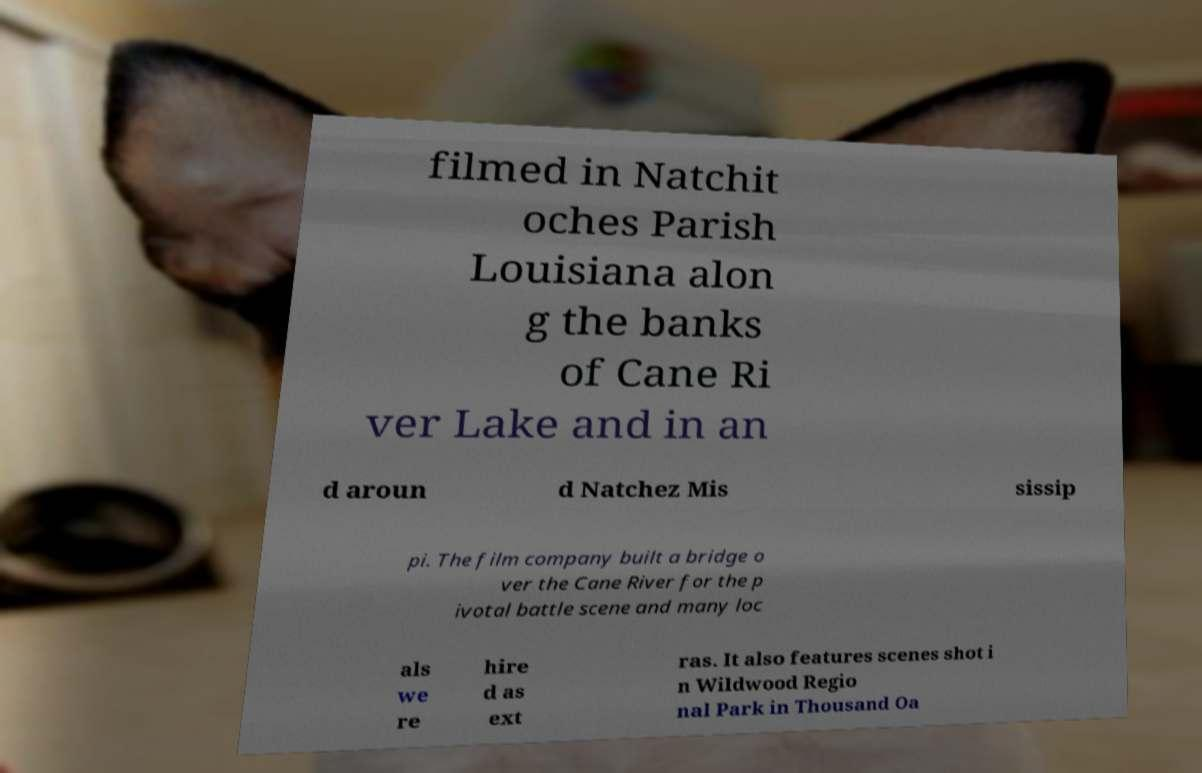Please identify and transcribe the text found in this image. filmed in Natchit oches Parish Louisiana alon g the banks of Cane Ri ver Lake and in an d aroun d Natchez Mis sissip pi. The film company built a bridge o ver the Cane River for the p ivotal battle scene and many loc als we re hire d as ext ras. It also features scenes shot i n Wildwood Regio nal Park in Thousand Oa 